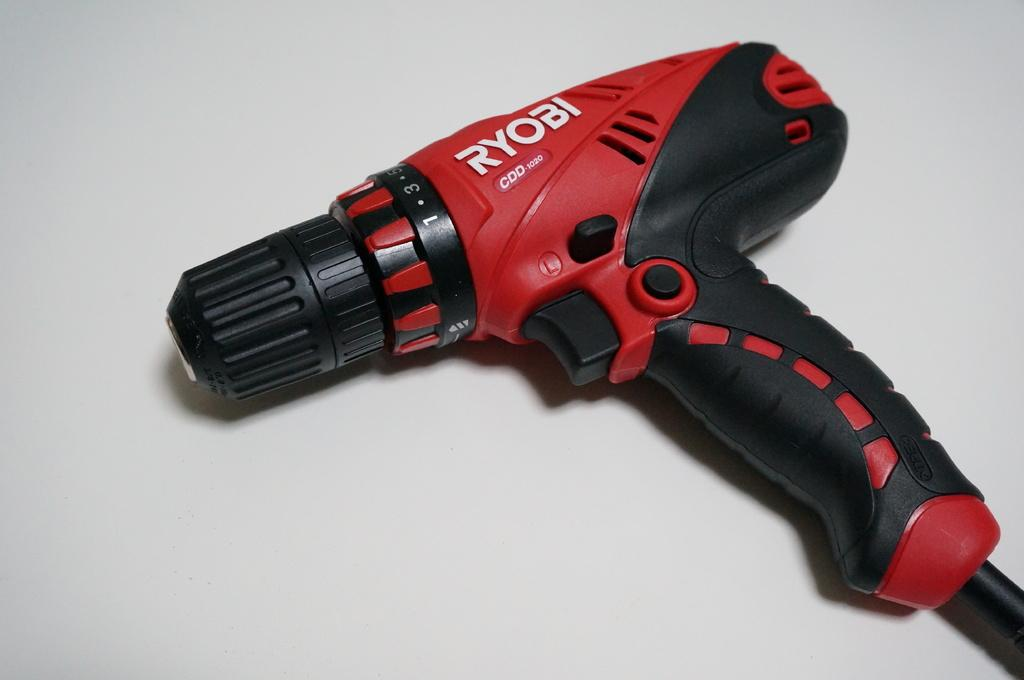What is the main object in the picture? There is a drilling machine in the picture. Where is the drilling machine located? The drilling machine is placed on a table. What type of engine is powering the volcano in the image? There is no volcano present in the image, and therefore no engine powering it. 